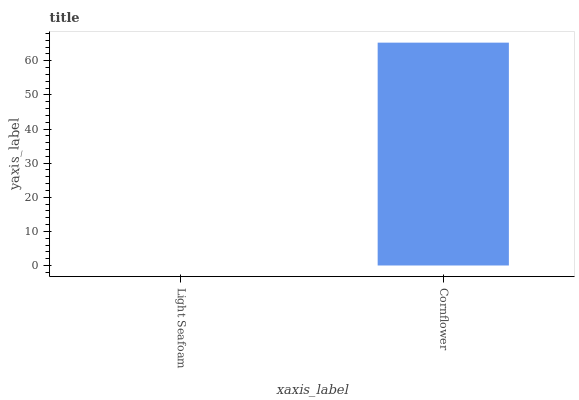Is Light Seafoam the minimum?
Answer yes or no. Yes. Is Cornflower the maximum?
Answer yes or no. Yes. Is Cornflower the minimum?
Answer yes or no. No. Is Cornflower greater than Light Seafoam?
Answer yes or no. Yes. Is Light Seafoam less than Cornflower?
Answer yes or no. Yes. Is Light Seafoam greater than Cornflower?
Answer yes or no. No. Is Cornflower less than Light Seafoam?
Answer yes or no. No. Is Cornflower the high median?
Answer yes or no. Yes. Is Light Seafoam the low median?
Answer yes or no. Yes. Is Light Seafoam the high median?
Answer yes or no. No. Is Cornflower the low median?
Answer yes or no. No. 